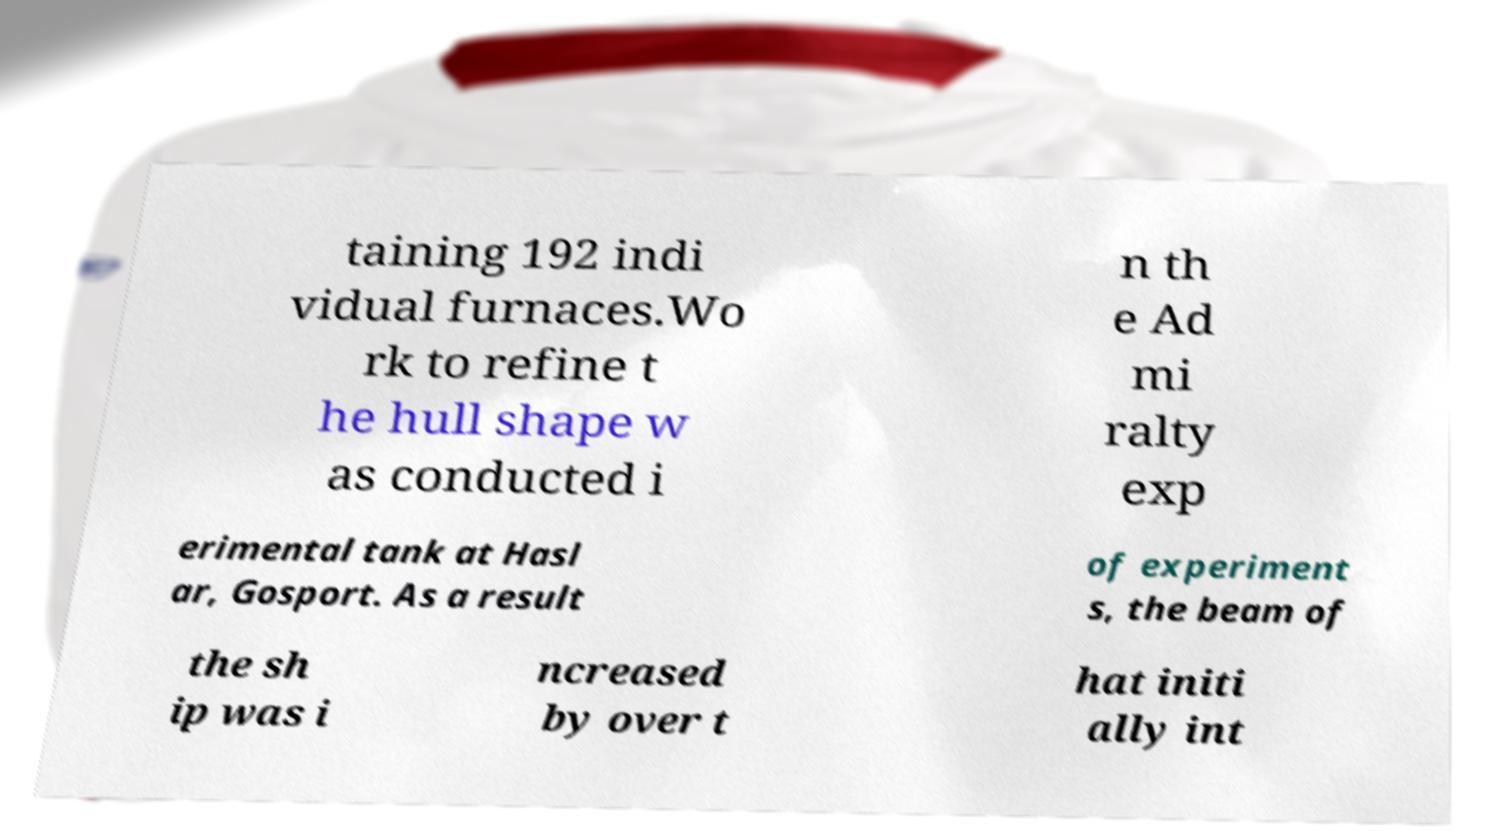Please read and relay the text visible in this image. What does it say? taining 192 indi vidual furnaces.Wo rk to refine t he hull shape w as conducted i n th e Ad mi ralty exp erimental tank at Hasl ar, Gosport. As a result of experiment s, the beam of the sh ip was i ncreased by over t hat initi ally int 